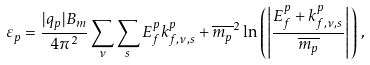<formula> <loc_0><loc_0><loc_500><loc_500>\varepsilon _ { p } = \frac { | q _ { p } | B _ { m } } { 4 \pi ^ { 2 } } \sum _ { \nu } \sum _ { s } E _ { f } ^ { p } k _ { f , \nu , s } ^ { p } + \overline { m _ { p } } ^ { 2 } \ln \left ( \left | \frac { E _ { f } ^ { p } + k _ { f , \nu , s } ^ { p } } { \overline { m _ { p } } } \right | \right ) \, ,</formula> 